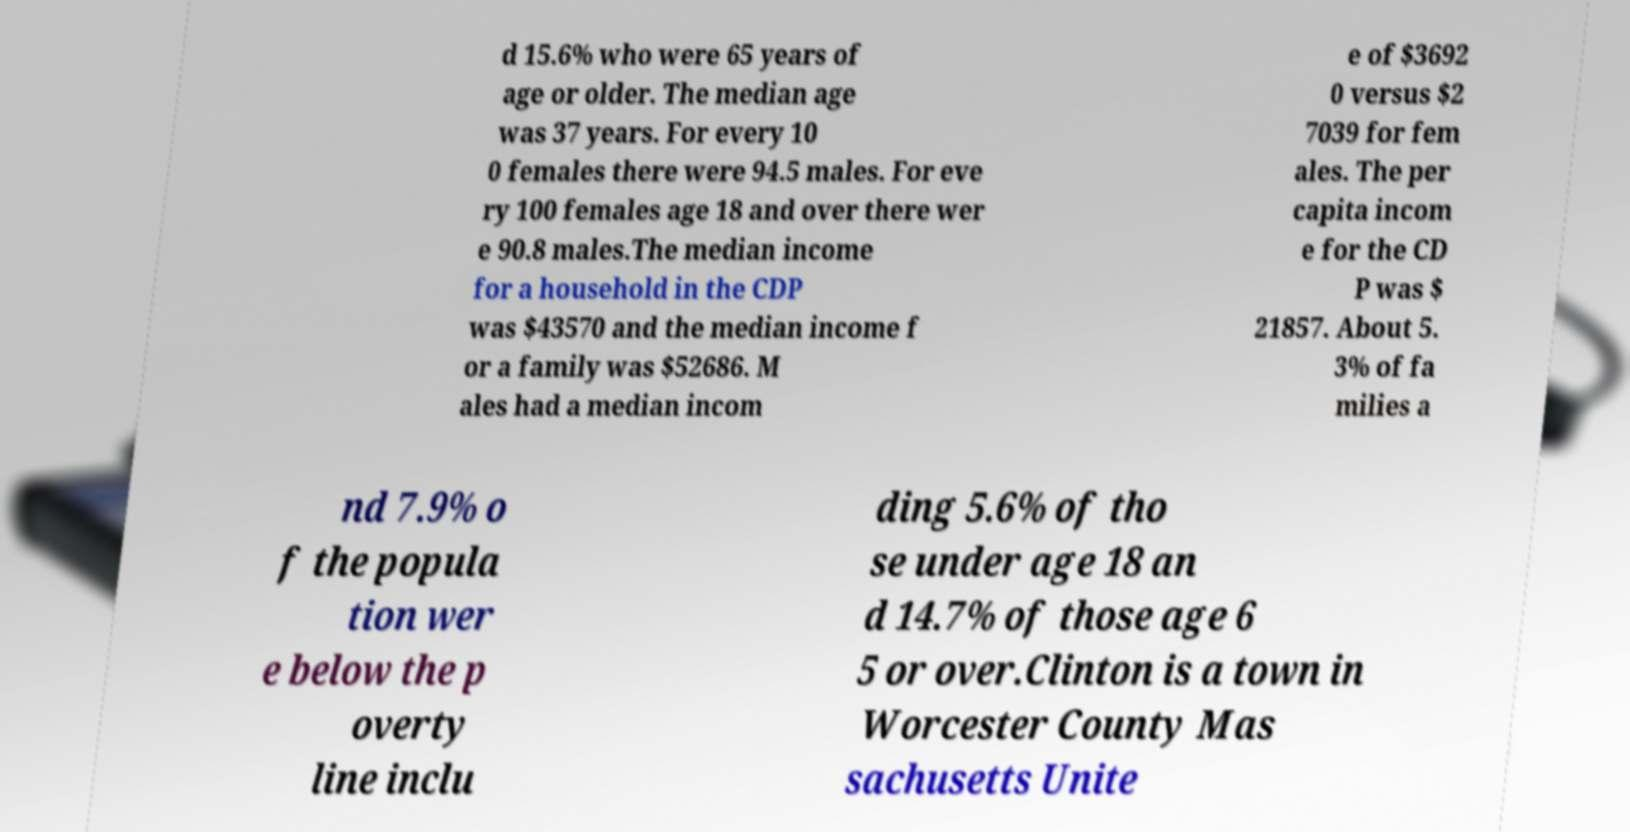Please identify and transcribe the text found in this image. d 15.6% who were 65 years of age or older. The median age was 37 years. For every 10 0 females there were 94.5 males. For eve ry 100 females age 18 and over there wer e 90.8 males.The median income for a household in the CDP was $43570 and the median income f or a family was $52686. M ales had a median incom e of $3692 0 versus $2 7039 for fem ales. The per capita incom e for the CD P was $ 21857. About 5. 3% of fa milies a nd 7.9% o f the popula tion wer e below the p overty line inclu ding 5.6% of tho se under age 18 an d 14.7% of those age 6 5 or over.Clinton is a town in Worcester County Mas sachusetts Unite 